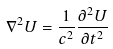<formula> <loc_0><loc_0><loc_500><loc_500>\nabla ^ { 2 } U = { \frac { 1 } { c ^ { 2 } } } { \frac { \partial ^ { 2 } U } { \partial t ^ { 2 } } }</formula> 